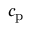<formula> <loc_0><loc_0><loc_500><loc_500>c _ { p }</formula> 